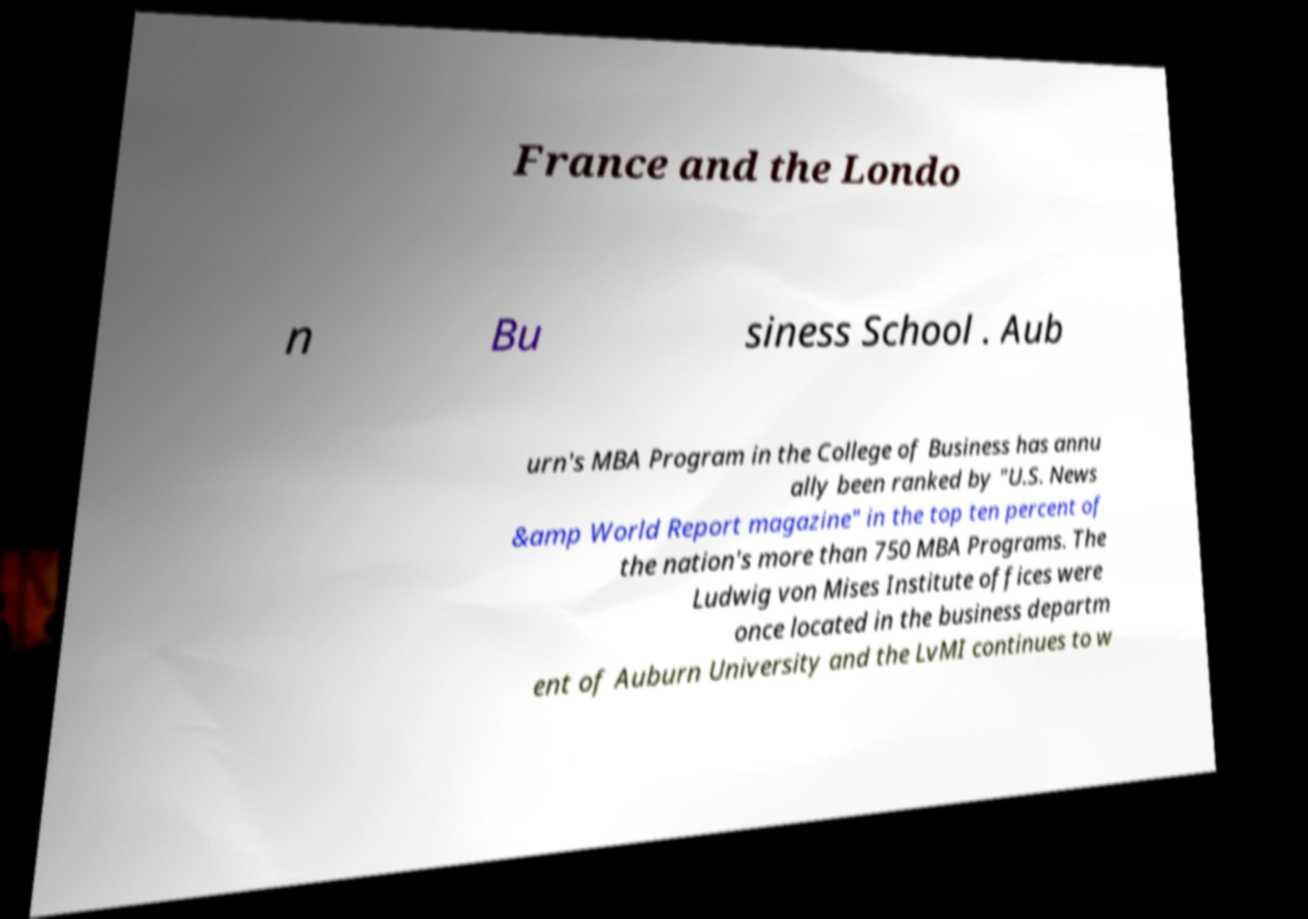For documentation purposes, I need the text within this image transcribed. Could you provide that? France and the Londo n Bu siness School . Aub urn's MBA Program in the College of Business has annu ally been ranked by "U.S. News &amp World Report magazine" in the top ten percent of the nation's more than 750 MBA Programs. The Ludwig von Mises Institute offices were once located in the business departm ent of Auburn University and the LvMI continues to w 